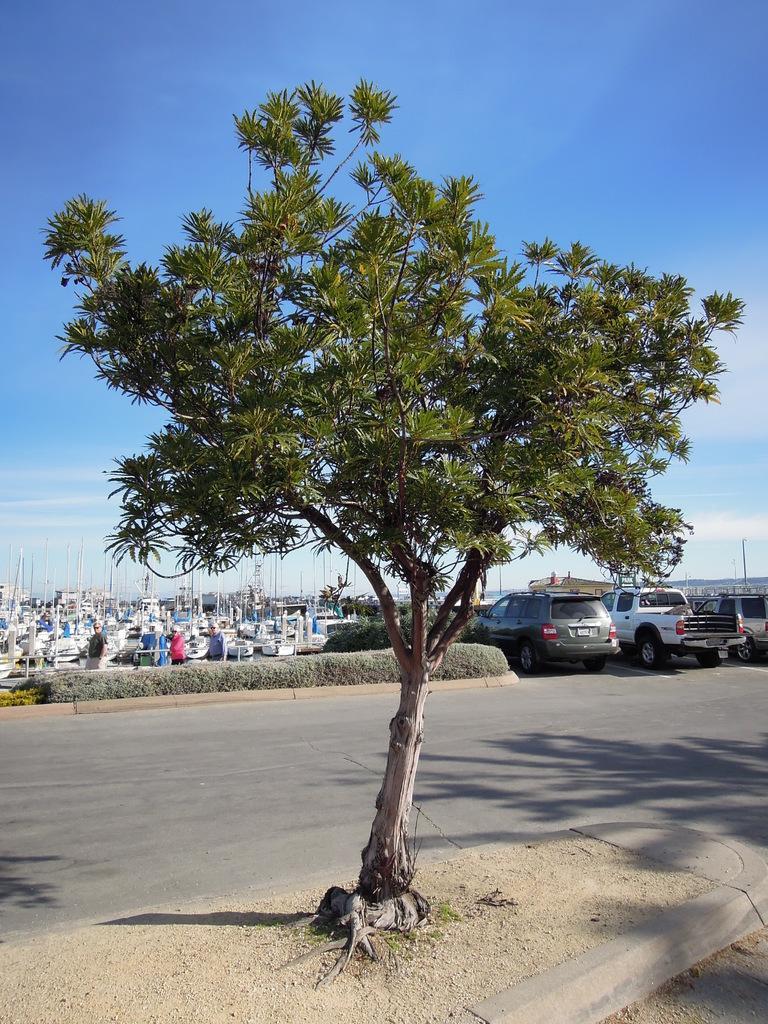Describe this image in one or two sentences. In the foreground of this image, there is a tree. Behind it, there is a road. In the middle, there are few vehicles and plants. In the background, it seems like boats, few people and the sky at the top. 